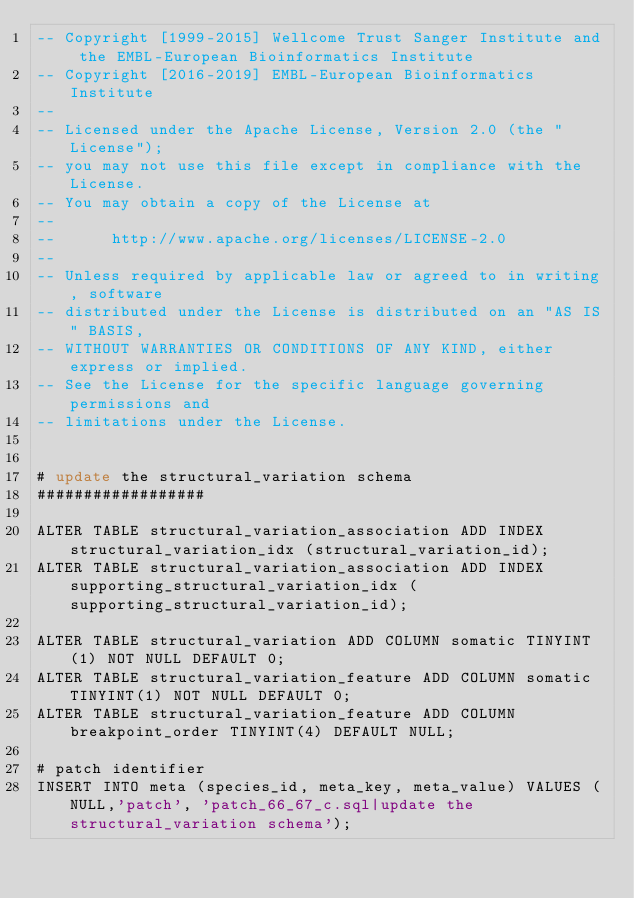Convert code to text. <code><loc_0><loc_0><loc_500><loc_500><_SQL_>-- Copyright [1999-2015] Wellcome Trust Sanger Institute and the EMBL-European Bioinformatics Institute
-- Copyright [2016-2019] EMBL-European Bioinformatics Institute
-- 
-- Licensed under the Apache License, Version 2.0 (the "License");
-- you may not use this file except in compliance with the License.
-- You may obtain a copy of the License at
-- 
--      http://www.apache.org/licenses/LICENSE-2.0
-- 
-- Unless required by applicable law or agreed to in writing, software
-- distributed under the License is distributed on an "AS IS" BASIS,
-- WITHOUT WARRANTIES OR CONDITIONS OF ANY KIND, either express or implied.
-- See the License for the specific language governing permissions and
-- limitations under the License.


# update the structural_variation schema
##################

ALTER TABLE structural_variation_association ADD INDEX structural_variation_idx (structural_variation_id);
ALTER TABLE structural_variation_association ADD INDEX supporting_structural_variation_idx (supporting_structural_variation_id);

ALTER TABLE structural_variation ADD COLUMN somatic TINYINT(1) NOT NULL DEFAULT 0;
ALTER TABLE structural_variation_feature ADD COLUMN somatic TINYINT(1) NOT NULL DEFAULT 0;
ALTER TABLE structural_variation_feature ADD COLUMN breakpoint_order TINYINT(4) DEFAULT NULL;

# patch identifier
INSERT INTO meta (species_id, meta_key, meta_value) VALUES (NULL,'patch', 'patch_66_67_c.sql|update the structural_variation schema');
</code> 